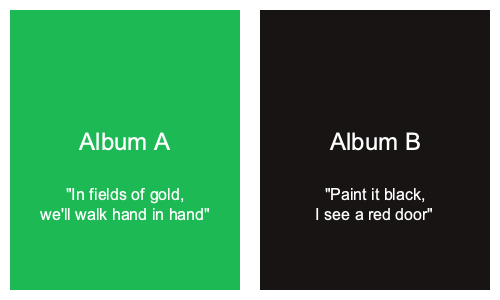Based on the album cover colors and the provided lyrics snippets, which album cover is most likely associated with the lyrics "Paint it black, I see a red door"? To answer this question, we need to analyze the relationship between the album cover colors and the given lyrics:

1. Album A:
   - Cover color: Green (#1DB954)
   - Lyrics: "In fields of gold, we'll walk hand in hand"
   
2. Album B:
   - Cover color: Black (#191414)
   - Lyrics: "Paint it black, I see a red door"

Step 1: Examine the color associations
- Album A's green color doesn't directly relate to the lyrics mentioning "fields of gold"
- Album B's black color directly corresponds to the phrase "Paint it black" in the lyrics

Step 2: Analyze the lyrical content
- Album A's lyrics describe a peaceful, nature-related scene
- Album B's lyrics explicitly mention the color black and a "red door"

Step 3: Match the lyrics to the album cover
- The lyrics "Paint it black, I see a red door" have a strong connection to Album B's black cover
- The contrast between the black cover and the mention of a "red door" in the lyrics creates a powerful visual imagery

Step 4: Consider the artistic coherence
- Album B demonstrates a clear relationship between its cover art (black) and the lyrics mentioning black, showing thoughtful composition

Given these considerations, the black cover of Album B is most likely associated with the lyrics "Paint it black, I see a red door" due to the direct color reference and thematic consistency.
Answer: Album B 